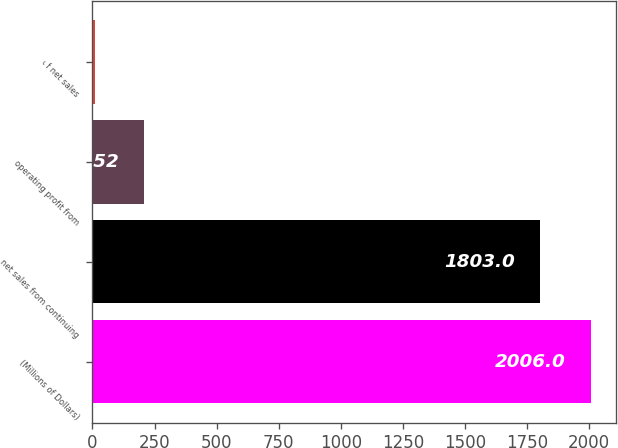<chart> <loc_0><loc_0><loc_500><loc_500><bar_chart><fcel>(Millions of Dollars)<fcel>net sales from continuing<fcel>operating profit from<fcel>of net sales<nl><fcel>2006<fcel>1803<fcel>208.52<fcel>8.8<nl></chart> 